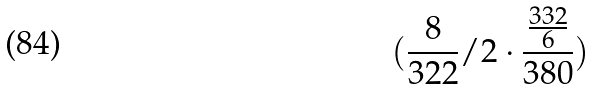Convert formula to latex. <formula><loc_0><loc_0><loc_500><loc_500>( \frac { 8 } { 3 2 2 } / 2 \cdot \frac { \frac { 3 3 2 } { 6 } } { 3 8 0 } )</formula> 